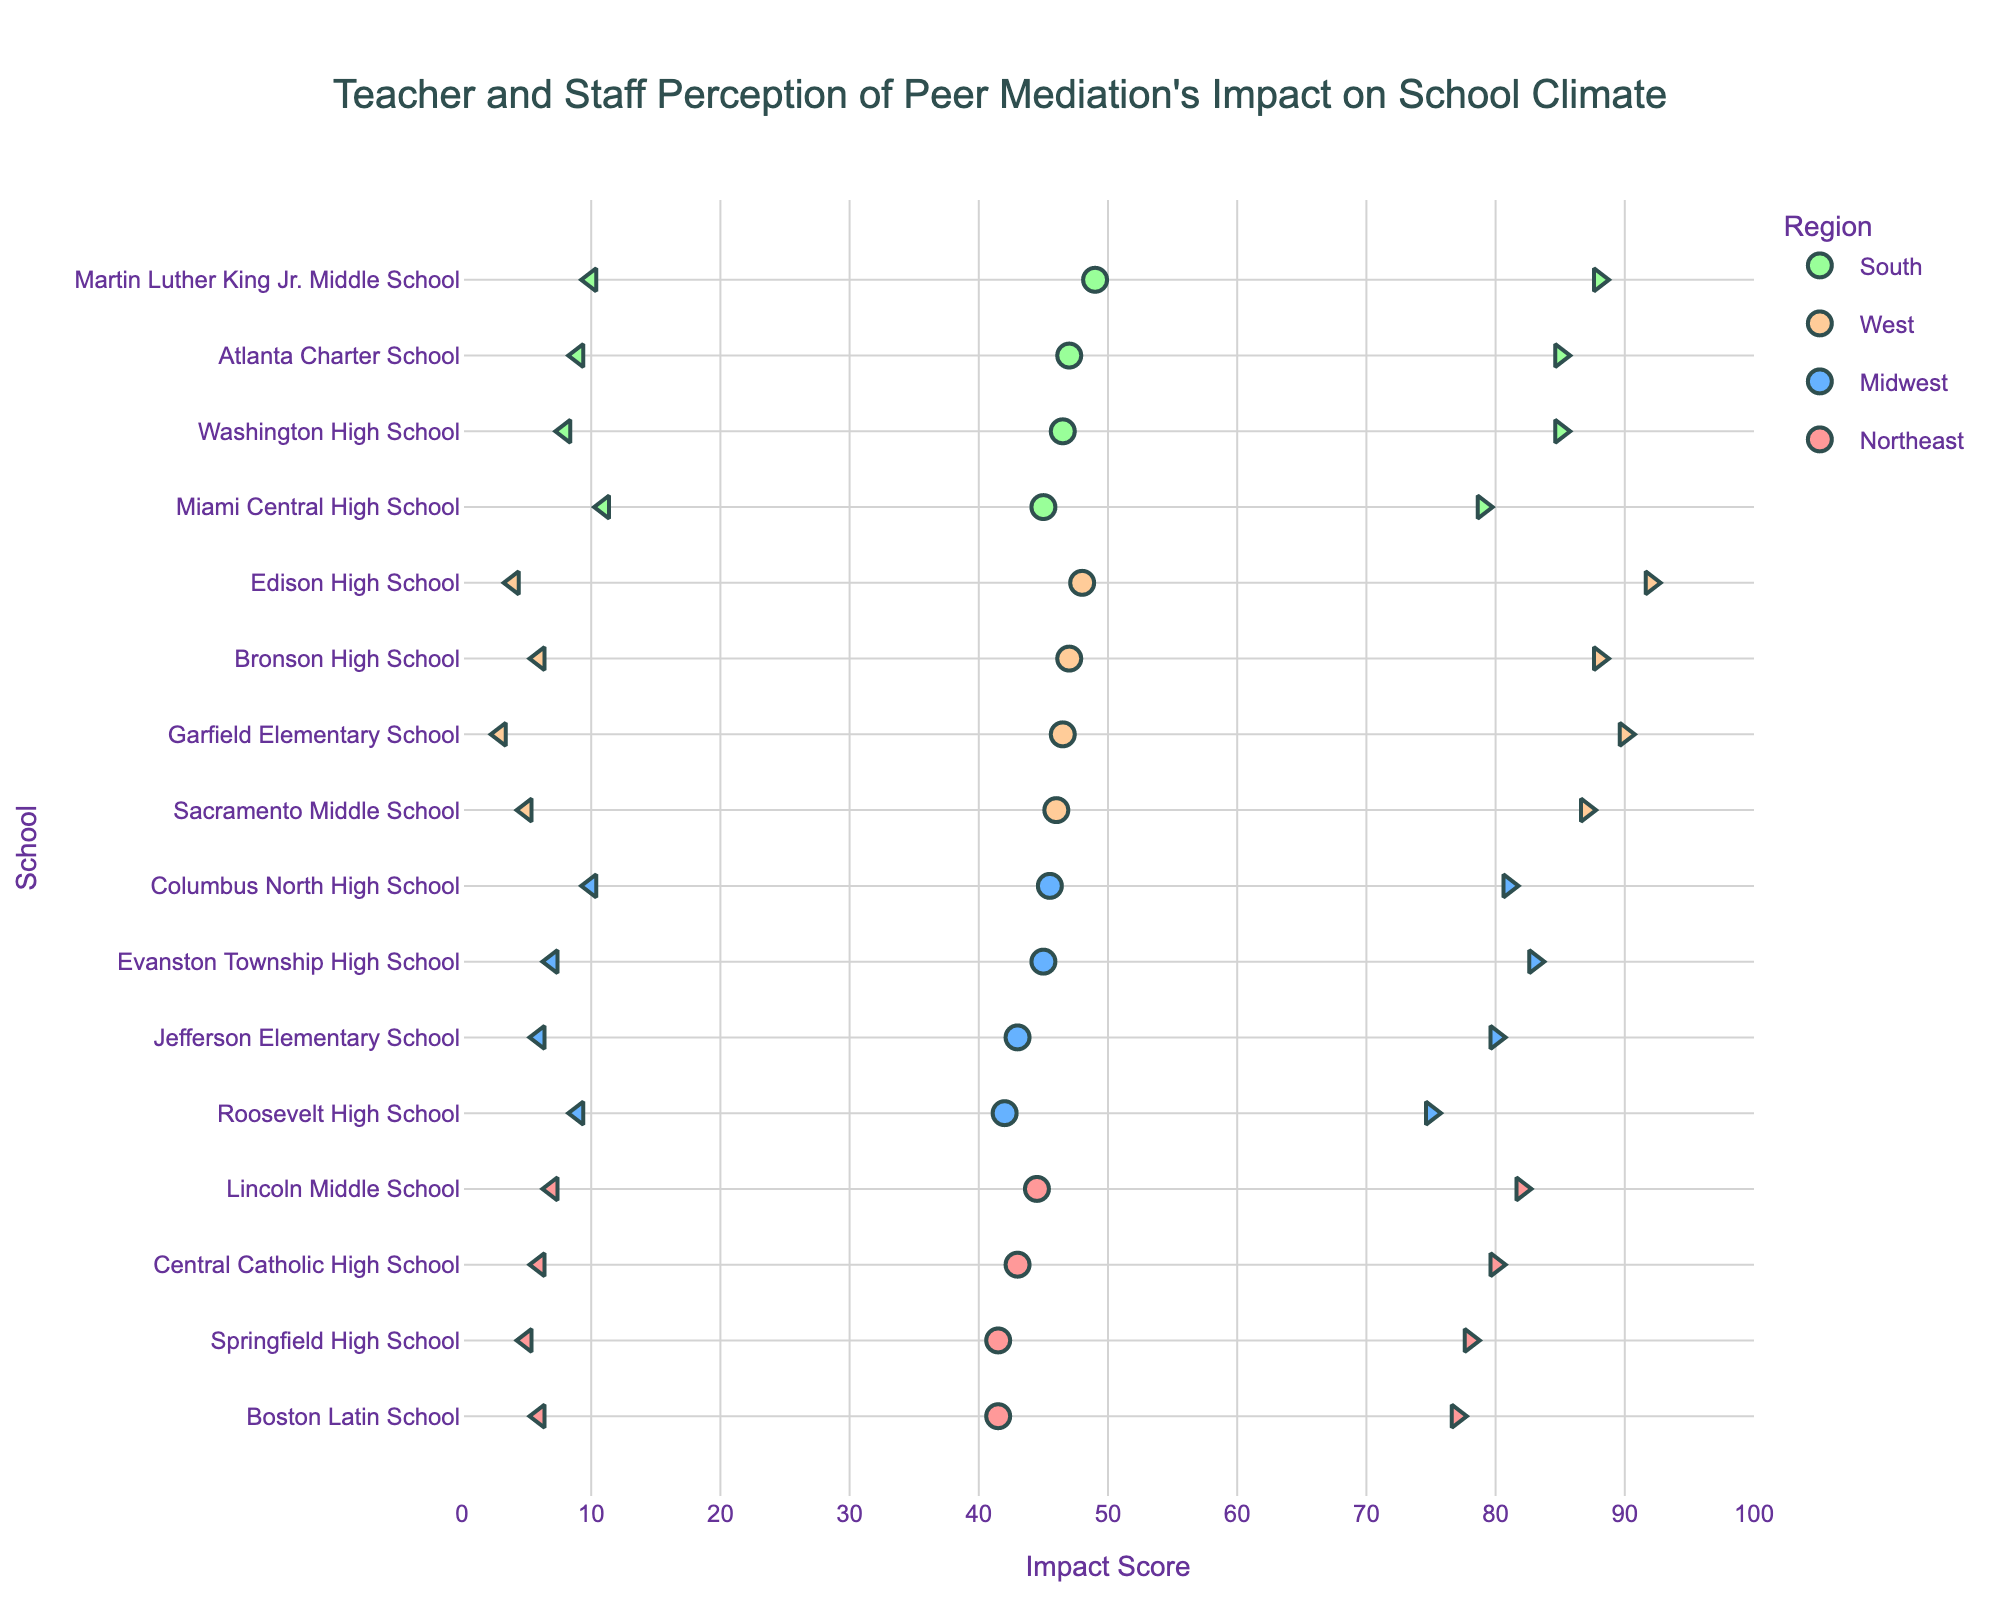What is the title of the figure? The title can be found at the top center of the figure and it fully describes what the figure is about.
Answer: Teacher and Staff Perception of Peer Mediation's Impact on School Climate What does the x-axis represent? The x-axis represents the "Impact Score" in the figure, and its label can be found below the x-axis line.
Answer: Impact Score Which region includes Springfield High School? To find out the region of Springfield High School, look for the school's name along the y-axis and check the color of the corresponding markers.
Answer: Northeast How many schools are shown for the South region? By locating the South region markers, which are in light green, and counting them along the y-axis, you can determine the number of schools in that region.
Answer: 5 What is the Positive Impact score for Garfield Elementary School? Locate Garfield Elementary School on the y-axis and check the position of the right-most (triangle-right) marker along the x-axis to read the Positive Impact score.
Answer: 90 Which school has the highest Mean Impact from the West region? First identify West region schools based on color (light orange). Then check the Mean Impact markers for each and find the one with the highest x-axis value.
Answer: Edison High School What school has the largest gap between Positive and Negative Impact scores in the West region? For each school in the West region, compute the difference between the Positive and Negative Impact scores, and find the school with the largest difference (triangle-right - triangle-left markers).
Answer: Edison High School What is the average Positive Impact score for schools in the Midwest region? Add the Positive Impact scores for all Midwest schools and divide by the number of Midwest schools: (75 + 80 + 83 + 81) / 4 = 79.75
Answer: 79.75 Which school in the South region has the highest Negative Impact score? Locate schools in the South region by their color (light green) and compare the positions of left-most (triangle-left) markers to determine the highest Negative Impact.
Answer: Miami Central High School Between Martin Luther King Jr. Middle School and Miami Central High School, which has a higher Positive Impact score? Compare the positions of the right-most (triangle-right) markers for both schools along the x-axis to determine which has a higher value.
Answer: Martin Luther King Jr. Middle School 